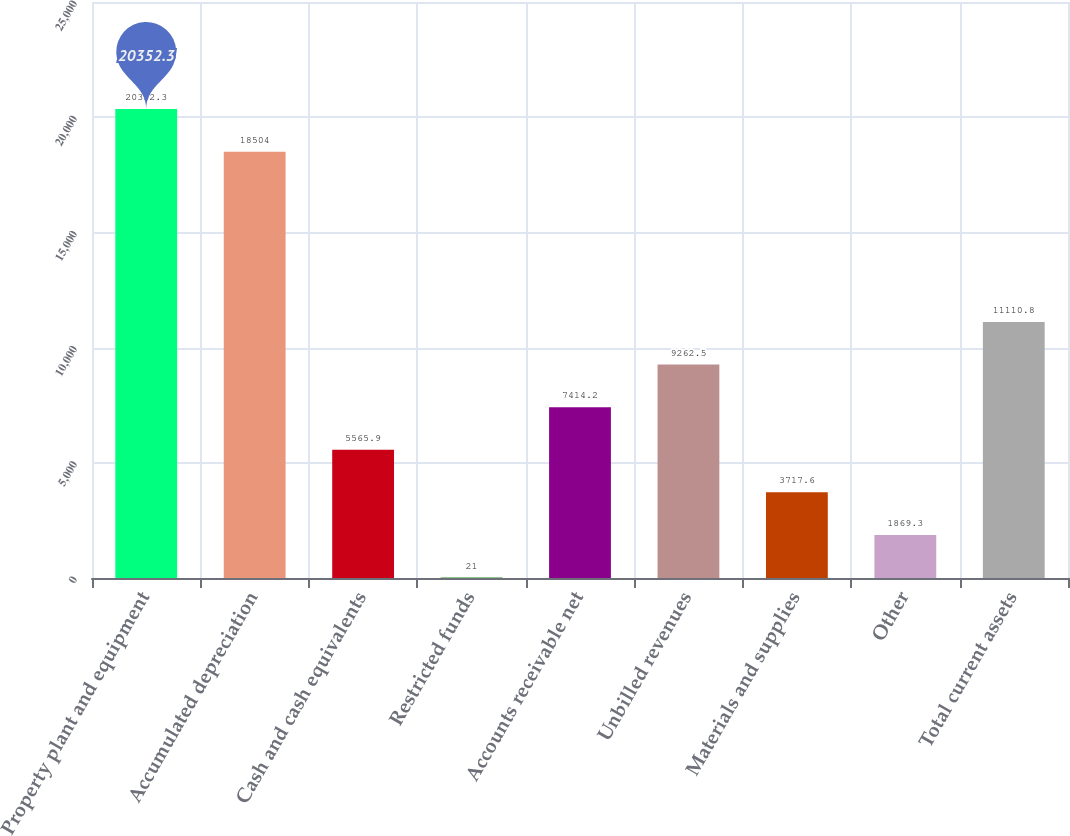<chart> <loc_0><loc_0><loc_500><loc_500><bar_chart><fcel>Property plant and equipment<fcel>Accumulated depreciation<fcel>Cash and cash equivalents<fcel>Restricted funds<fcel>Accounts receivable net<fcel>Unbilled revenues<fcel>Materials and supplies<fcel>Other<fcel>Total current assets<nl><fcel>20352.3<fcel>18504<fcel>5565.9<fcel>21<fcel>7414.2<fcel>9262.5<fcel>3717.6<fcel>1869.3<fcel>11110.8<nl></chart> 